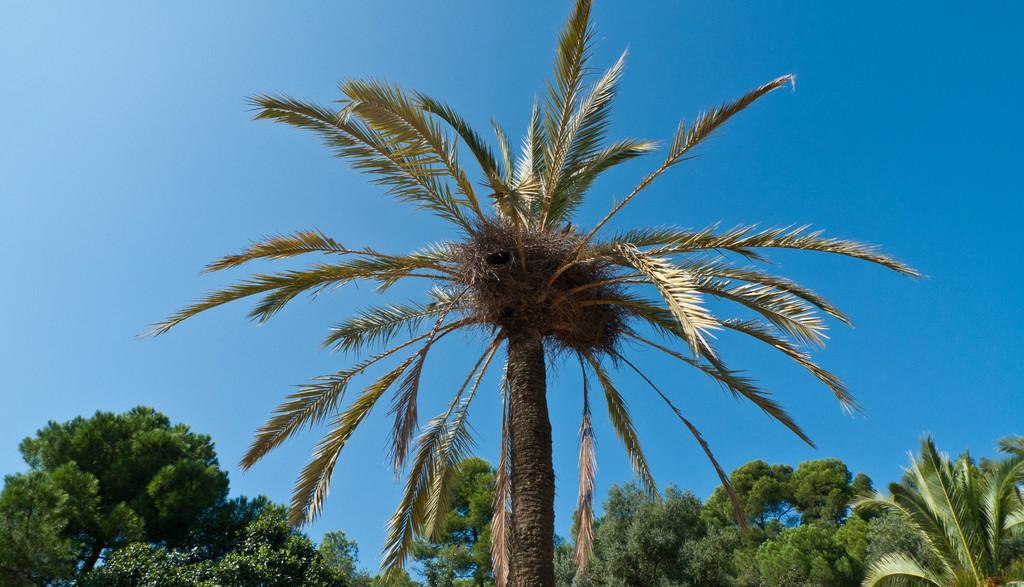What type of vegetation can be seen in the image? There are trees in the image. What color is the sky in the image? The sky in the image has a blue color. How many frogs are sitting on the pencil in the image? There are no frogs or pencils present in the image. Is there an island visible in the image? There is no island visible in the image. 